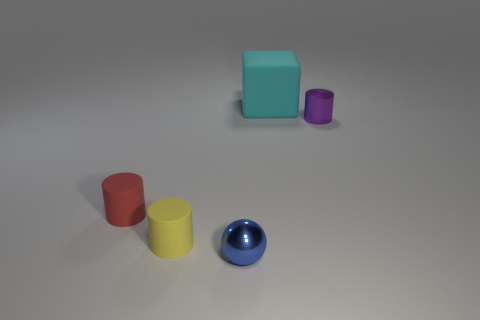What number of other things are there of the same shape as the yellow matte object?
Your answer should be very brief. 2. What shape is the small metallic object left of the large matte block that is left of the small cylinder that is on the right side of the tiny blue ball?
Offer a terse response. Sphere. How many things are either big green cubes or shiny objects that are to the right of the sphere?
Give a very brief answer. 1. Is the shape of the small shiny object in front of the yellow object the same as the big thing to the left of the metal cylinder?
Offer a very short reply. No. How many things are either small gray metallic cubes or red things?
Your answer should be compact. 1. Are there any other things that have the same material as the big cyan object?
Your answer should be very brief. Yes. Are any cyan cubes visible?
Provide a short and direct response. Yes. Is the thing behind the small purple metallic cylinder made of the same material as the blue thing?
Keep it short and to the point. No. Is there another small yellow object of the same shape as the yellow object?
Keep it short and to the point. No. Are there the same number of shiny cylinders that are to the right of the small purple shiny thing and yellow metallic balls?
Give a very brief answer. Yes. 